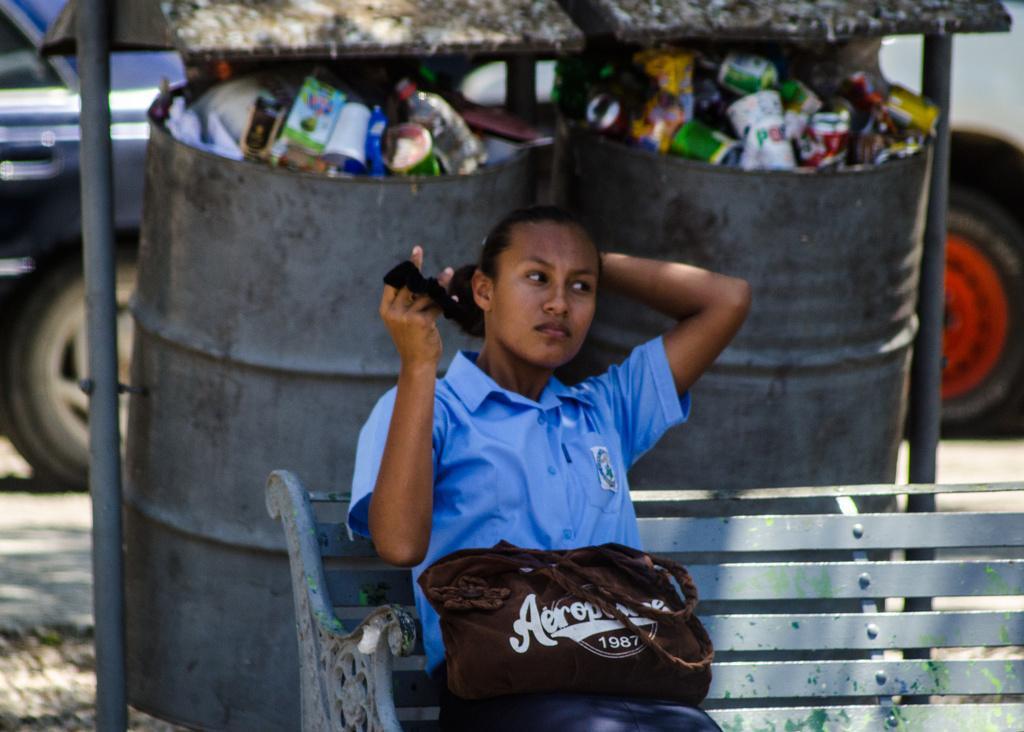Describe this image in one or two sentences. There is a lady sitting on a bench. There is a brown color bag with something written on that is on her lap. In the back there are barrels. Inside that there are wastes like bottles, cups and many other things. Also there is a shed with poles for the barrels. In the background there are vehicles. 